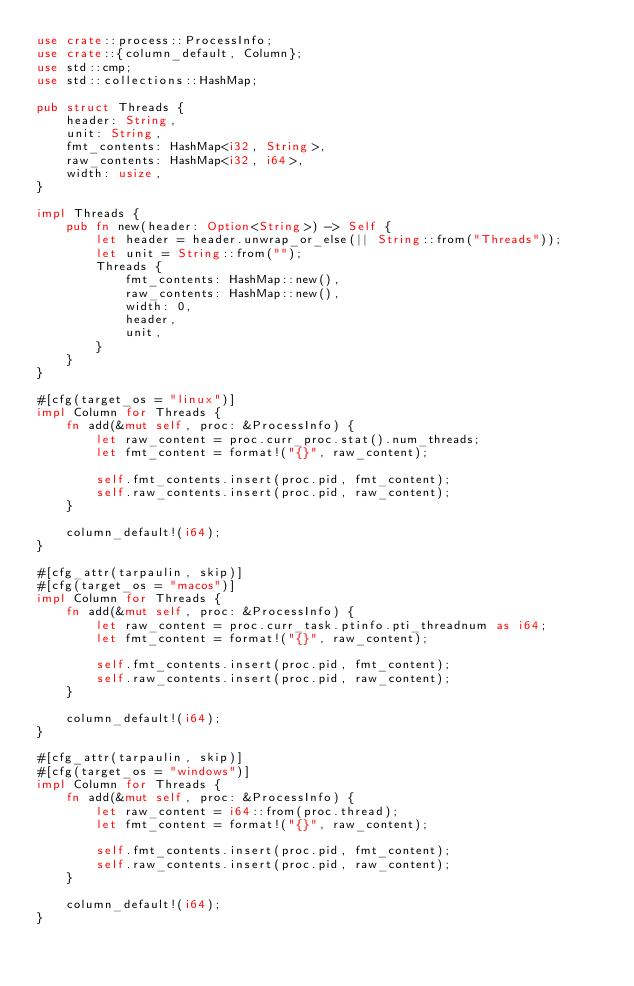Convert code to text. <code><loc_0><loc_0><loc_500><loc_500><_Rust_>use crate::process::ProcessInfo;
use crate::{column_default, Column};
use std::cmp;
use std::collections::HashMap;

pub struct Threads {
    header: String,
    unit: String,
    fmt_contents: HashMap<i32, String>,
    raw_contents: HashMap<i32, i64>,
    width: usize,
}

impl Threads {
    pub fn new(header: Option<String>) -> Self {
        let header = header.unwrap_or_else(|| String::from("Threads"));
        let unit = String::from("");
        Threads {
            fmt_contents: HashMap::new(),
            raw_contents: HashMap::new(),
            width: 0,
            header,
            unit,
        }
    }
}

#[cfg(target_os = "linux")]
impl Column for Threads {
    fn add(&mut self, proc: &ProcessInfo) {
        let raw_content = proc.curr_proc.stat().num_threads;
        let fmt_content = format!("{}", raw_content);

        self.fmt_contents.insert(proc.pid, fmt_content);
        self.raw_contents.insert(proc.pid, raw_content);
    }

    column_default!(i64);
}

#[cfg_attr(tarpaulin, skip)]
#[cfg(target_os = "macos")]
impl Column for Threads {
    fn add(&mut self, proc: &ProcessInfo) {
        let raw_content = proc.curr_task.ptinfo.pti_threadnum as i64;
        let fmt_content = format!("{}", raw_content);

        self.fmt_contents.insert(proc.pid, fmt_content);
        self.raw_contents.insert(proc.pid, raw_content);
    }

    column_default!(i64);
}

#[cfg_attr(tarpaulin, skip)]
#[cfg(target_os = "windows")]
impl Column for Threads {
    fn add(&mut self, proc: &ProcessInfo) {
        let raw_content = i64::from(proc.thread);
        let fmt_content = format!("{}", raw_content);

        self.fmt_contents.insert(proc.pid, fmt_content);
        self.raw_contents.insert(proc.pid, raw_content);
    }

    column_default!(i64);
}
</code> 